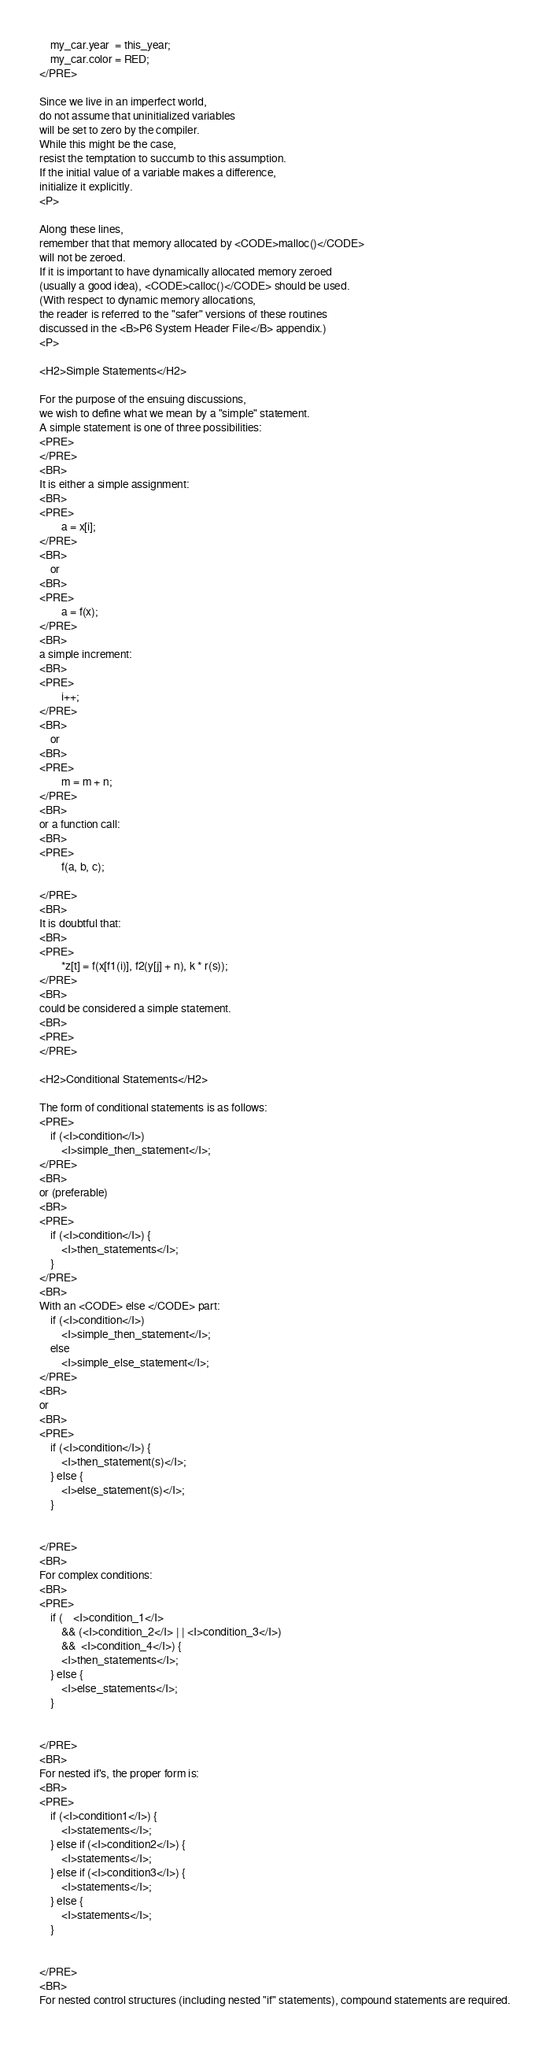Convert code to text. <code><loc_0><loc_0><loc_500><loc_500><_HTML_>	my_car.year  = this_year;
	my_car.color = RED;
</PRE>

Since we live in an imperfect world,
do not assume that uninitialized variables
will be set to zero by the compiler.
While this might be the case,
resist the temptation to succumb to this assumption.
If the initial value of a variable makes a difference,
initialize it explicitly.
<P>

Along these lines,
remember that that memory allocated by <CODE>malloc()</CODE>
will not be zeroed.
If it is important to have dynamically allocated memory zeroed
(usually a good idea), <CODE>calloc()</CODE> should be used.
(With respect to dynamic memory allocations,
the reader is referred to the "safer" versions of these routines
discussed in the <B>P6 System Header File</B> appendix.)
<P>

<H2>Simple Statements</H2>

For the purpose of the ensuing discussions,
we wish to define what we mean by a "simple" statement.
A simple statement is one of three possibilities:
<PRE>
</PRE>
<BR>
It is either a simple assignment:
<BR>
<PRE>
		a = x[i];
</PRE>
<BR>
	or
<BR>
<PRE>
		a = f(x);
</PRE>
<BR>
a simple increment:
<BR>
<PRE>
		i++;
</PRE>
<BR>
	or
<BR>
<PRE>
		m = m + n;
</PRE>
<BR>
or a function call:
<BR>
<PRE>
		f(a, b, c);

</PRE>
<BR>
It is doubtful that:
<BR>
<PRE>
		*z[t] = f(x[f1(i)], f2(y[j] + n), k * r(s));
</PRE>
<BR>
could be considered a simple statement.
<BR>
<PRE>
</PRE>

<H2>Conditional Statements</H2>

The form of conditional statements is as follows:
<PRE>
	if (<I>condition</I>)
		<I>simple_then_statement</I>;
</PRE>
<BR>
or (preferable)
<BR>
<PRE>
	if (<I>condition</I>) {
		<I>then_statements</I>;
	}
</PRE>
<BR>
With an <CODE> else </CODE> part:
	if (<I>condition</I>)
		<I>simple_then_statement</I>;
	else
		<I>simple_else_statement</I>;
</PRE>
<BR>
or
<BR>
<PRE>
	if (<I>condition</I>) {
		<I>then_statement(s)</I>;
	} else {
		<I>else_statement(s)</I>;
	}


</PRE>
<BR>
For complex conditions:
<BR>
<PRE>
	if (    <I>condition_1</I>
	    && (<I>condition_2</I> | | <I>condition_3</I>)
	    &&  <I>condition_4</I>) {
		<I>then_statements</I>;
	} else {
		<I>else_statements</I>;
	}


</PRE>
<BR>
For nested if's, the proper form is:
<BR>
<PRE>
	if (<I>condition1</I>) {
		<I>statements</I>;
	} else if (<I>condition2</I>) {
		<I>statements</I>;
	} else if (<I>condition3</I>) {
		<I>statements</I>;
	} else {
		<I>statements</I>;
	}


</PRE>
<BR>
For nested control structures (including nested "if" statements), compound statements are required.</code> 